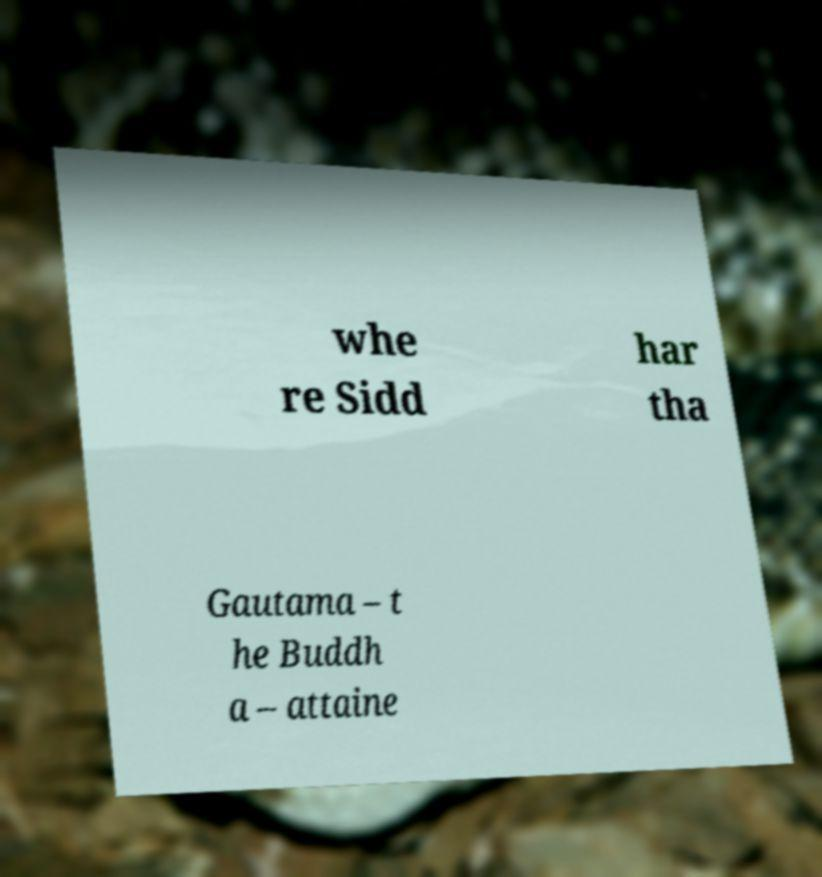Can you accurately transcribe the text from the provided image for me? whe re Sidd har tha Gautama – t he Buddh a – attaine 